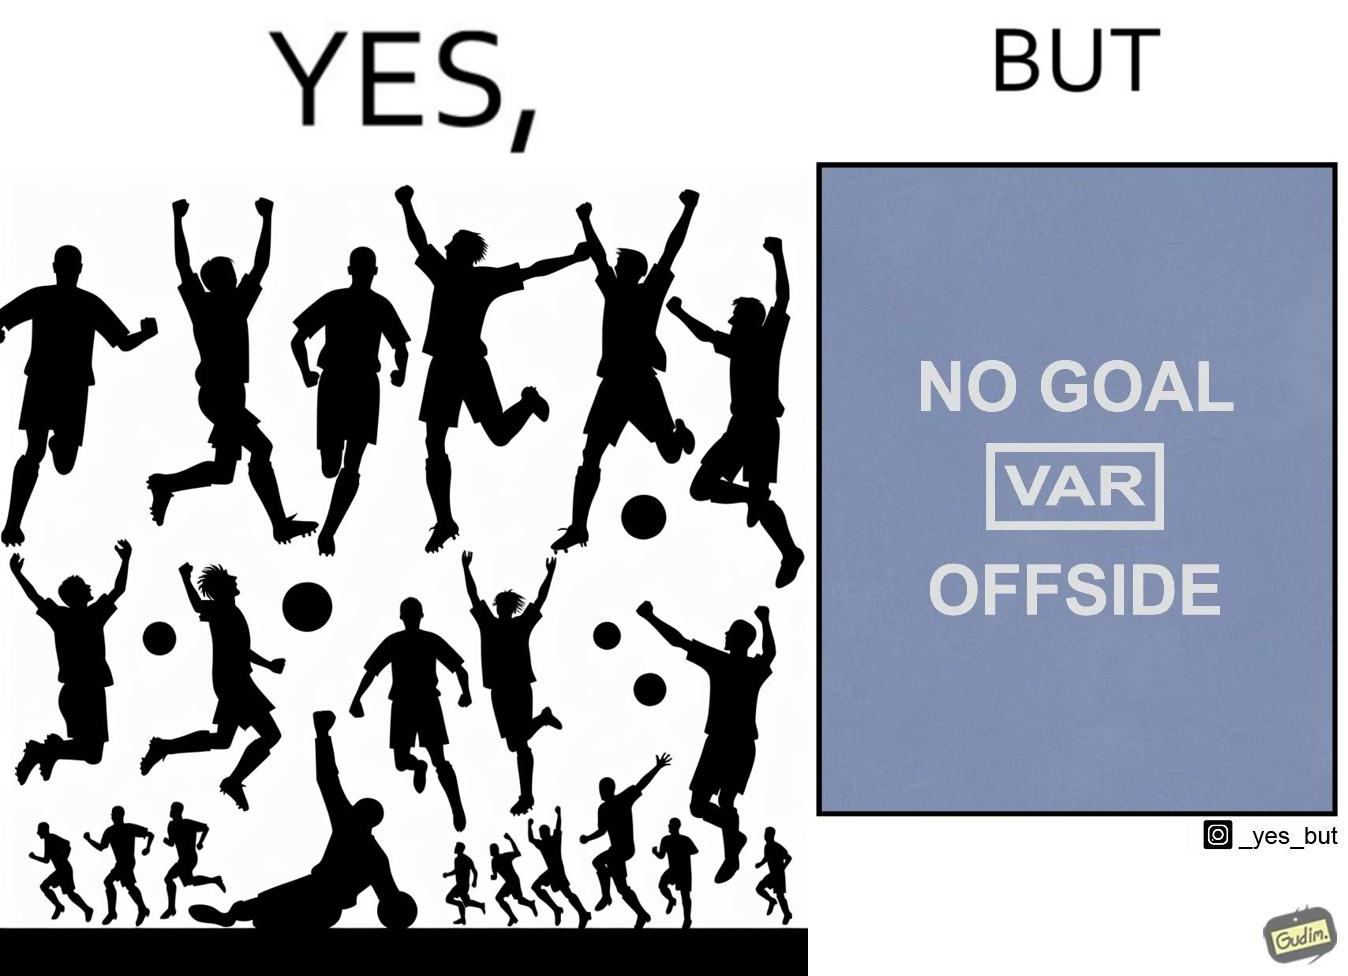Explain why this image is satirical. The image is ironical, as the team is celebrating as they think that they have scored a goal, but the sign on the screen says that it is an offside, and not a goal. This is a very common scenario in football matches. 